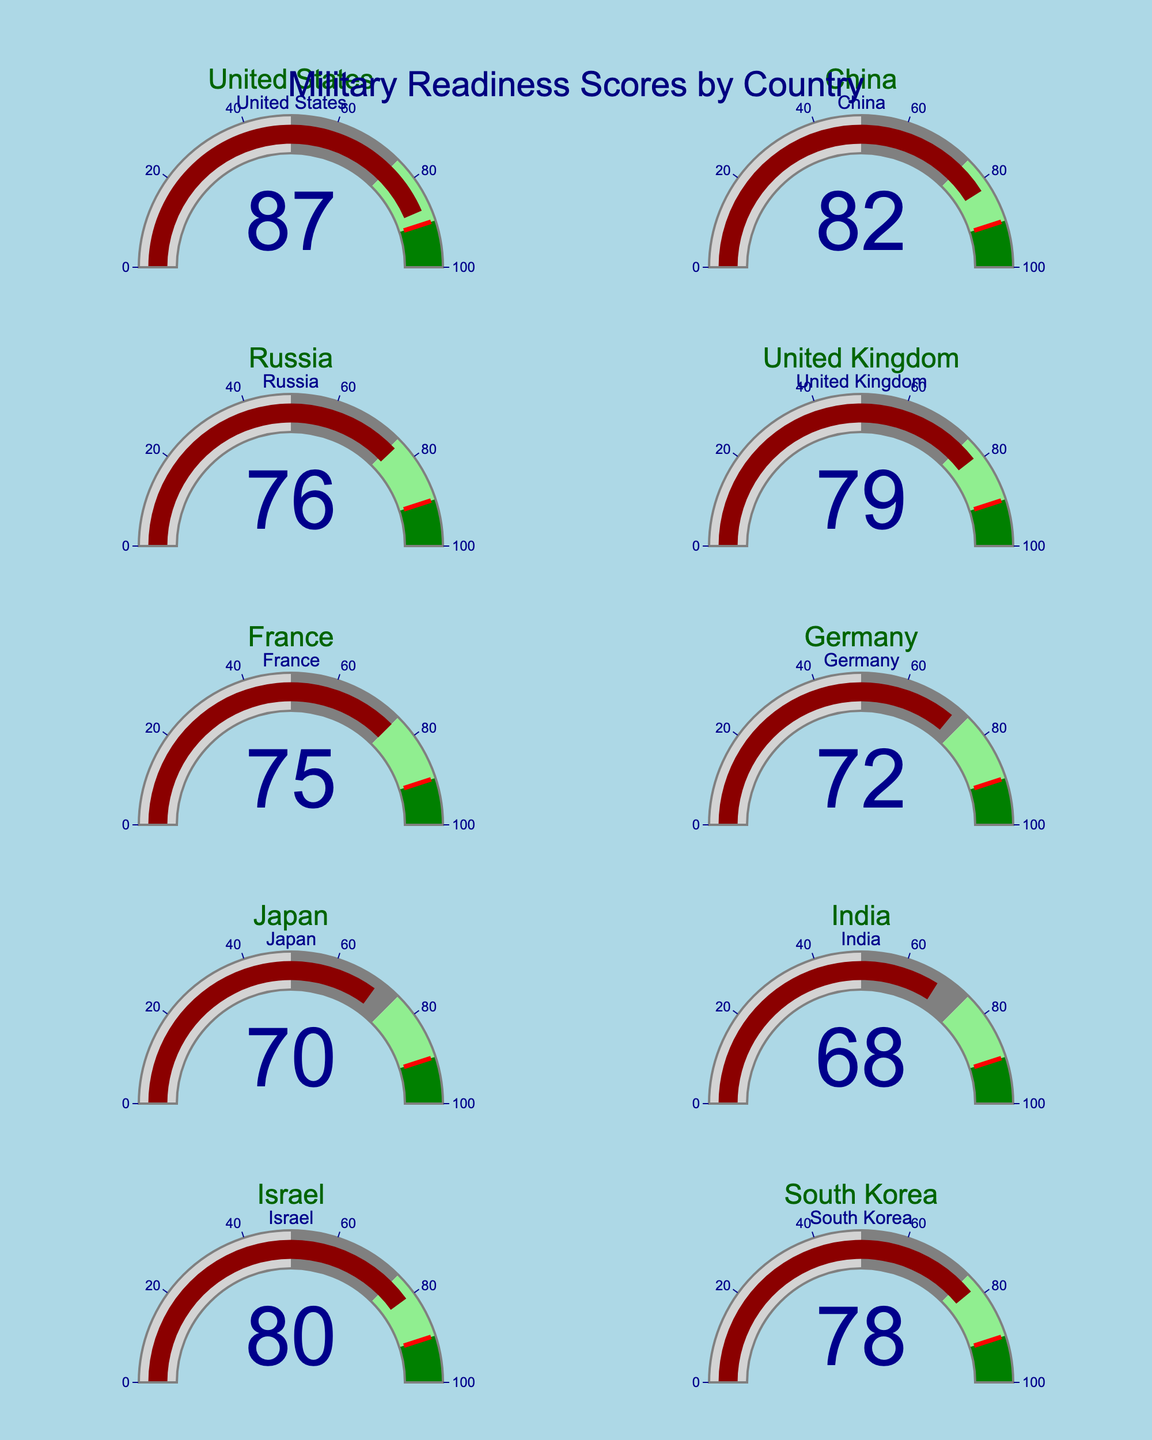what is the range of readiness scores represented on the gauges? The range of readiness scores shown is from 0 to 100. Each gauge has a labeled scale starting at 0 and going up to 100.
Answer: 0 to 100 Which country has the highest readiness score? By looking at the values displayed on each gauge, the United States has the highest readiness score of 87.
Answer: The United States Which country has the lowest readiness score? Upon examining the gauges, India has the lowest readiness score, which is 68.
Answer: India How many countries have a readiness score greater than 80? From the values shown, the countries with readiness scores over 80 are the United States (87), China (82), and Israel (80). Hence, there are 3 countries with a readiness score greater than 80.
Answer: 3 What is the average readiness score of all the countries represented in the figure? To find the average readiness score, add all scores and divide by the number of countries. The sum is 87 + 82 + 76 + 79 + 75 + 72 + 70 + 68 + 80 + 78 = 767. Dividing by 10 countries gives an average of 76.7.
Answer: 76.7 Which countries have a readiness score between 70 and 80? Checking the gauges, the countries with scores between 70 and 80 are Russia (76), United Kingdom (79), France (75), Germany (72), Japan (70), and South Korea (78).
Answer: Russia, United Kingdom, France, Germany, Japan, South Korea Is there any country with a readiness score exactly at the threshold value indicated on the gauge? The threshold value on each gauge is indicated as 90. Examining the displayed data, no country achieves exactly this value.
Answer: No What is the combined readiness score of Israel and Germany? Adding the readiness scores of Israel (80) and Germany (72) gives a combined score of 80 + 72 = 152.
Answer: 152 Which countries' readiness scores fall in the light green section of the gauges? The light green section represents scores between 75 and 90. The countries within this range are the United States (87), China (82), Russia (76), United Kingdom (79), Israel (80), and South Korea (78).
Answer: United States, China, Russia, United Kingdom, Israel, South Korea 